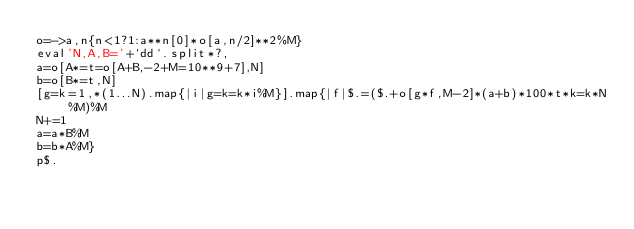Convert code to text. <code><loc_0><loc_0><loc_500><loc_500><_Ruby_>o=->a,n{n<1?1:a**n[0]*o[a,n/2]**2%M}
eval'N,A,B='+`dd`.split*?,
a=o[A*=t=o[A+B,-2+M=10**9+7],N]
b=o[B*=t,N]
[g=k=1,*(1...N).map{|i|g=k=k*i%M}].map{|f|$.=($.+o[g*f,M-2]*(a+b)*100*t*k=k*N%M)%M
N+=1
a=a*B%M
b=b*A%M}
p$.</code> 